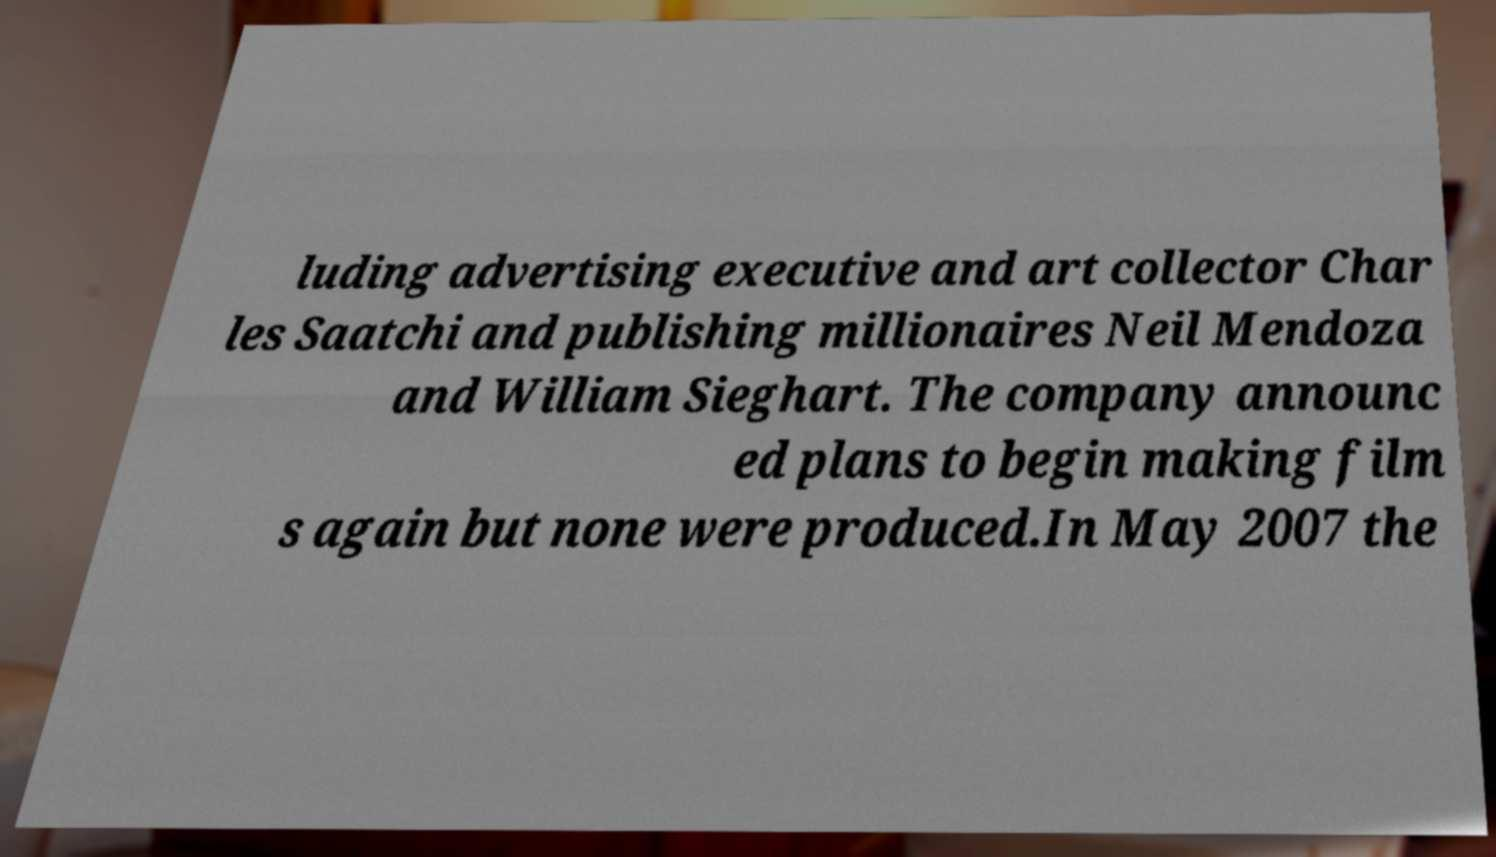Please read and relay the text visible in this image. What does it say? luding advertising executive and art collector Char les Saatchi and publishing millionaires Neil Mendoza and William Sieghart. The company announc ed plans to begin making film s again but none were produced.In May 2007 the 